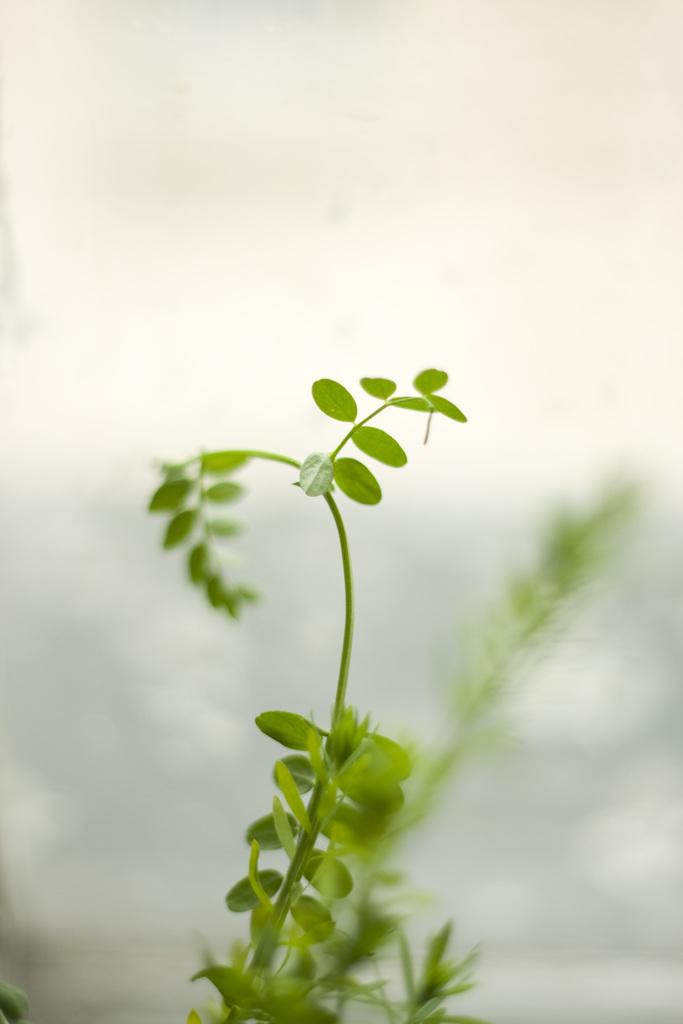What is the main subject of the image? The main subject of the image is the leaves of a plant. Can you describe the background of the image? The background of the image is blurry. What type of umbrella is being used to protect the leaves from the rain in the image? There is no umbrella present in the image, and the leaves are not being protected from the rain. How many screws can be seen holding the leaves together in the image? There are no screws visible in the image, as leaves are not typically held together by screws. 